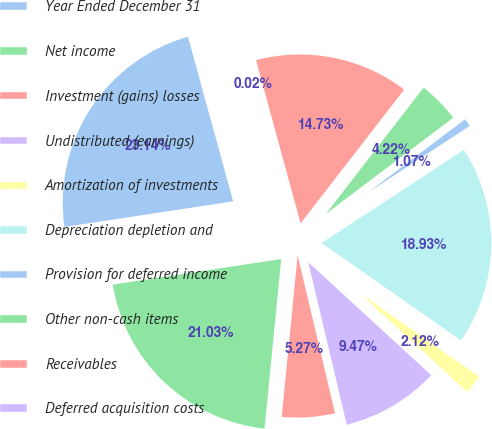Convert chart to OTSL. <chart><loc_0><loc_0><loc_500><loc_500><pie_chart><fcel>Year Ended December 31<fcel>Net income<fcel>Investment (gains) losses<fcel>Undistributed (earnings)<fcel>Amortization of investments<fcel>Depreciation depletion and<fcel>Provision for deferred income<fcel>Other non-cash items<fcel>Receivables<fcel>Deferred acquisition costs<nl><fcel>23.14%<fcel>21.03%<fcel>5.27%<fcel>9.47%<fcel>2.12%<fcel>18.93%<fcel>1.07%<fcel>4.22%<fcel>14.73%<fcel>0.02%<nl></chart> 